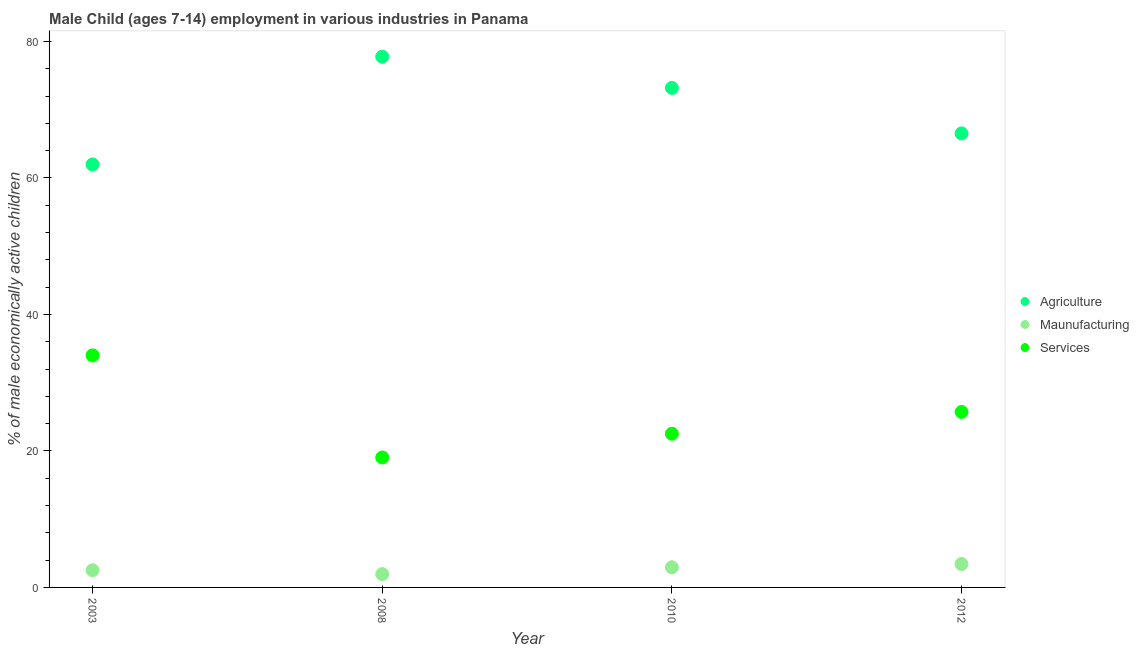How many different coloured dotlines are there?
Offer a very short reply. 3. What is the percentage of economically active children in manufacturing in 2003?
Your answer should be compact. 2.52. Across all years, what is the maximum percentage of economically active children in agriculture?
Give a very brief answer. 77.76. Across all years, what is the minimum percentage of economically active children in manufacturing?
Your answer should be very brief. 1.95. What is the total percentage of economically active children in agriculture in the graph?
Your response must be concise. 279.44. What is the difference between the percentage of economically active children in manufacturing in 2010 and that in 2012?
Keep it short and to the point. -0.48. What is the difference between the percentage of economically active children in manufacturing in 2012 and the percentage of economically active children in agriculture in 2008?
Offer a terse response. -74.33. What is the average percentage of economically active children in manufacturing per year?
Your answer should be compact. 2.71. In the year 2003, what is the difference between the percentage of economically active children in agriculture and percentage of economically active children in services?
Offer a terse response. 27.97. What is the ratio of the percentage of economically active children in manufacturing in 2003 to that in 2012?
Your answer should be very brief. 0.73. Is the difference between the percentage of economically active children in agriculture in 2003 and 2012 greater than the difference between the percentage of economically active children in manufacturing in 2003 and 2012?
Offer a very short reply. No. What is the difference between the highest and the second highest percentage of economically active children in manufacturing?
Your answer should be very brief. 0.48. What is the difference between the highest and the lowest percentage of economically active children in services?
Give a very brief answer. 14.96. Is the sum of the percentage of economically active children in agriculture in 2003 and 2008 greater than the maximum percentage of economically active children in manufacturing across all years?
Offer a very short reply. Yes. Is the percentage of economically active children in manufacturing strictly greater than the percentage of economically active children in services over the years?
Ensure brevity in your answer.  No. Is the percentage of economically active children in services strictly less than the percentage of economically active children in manufacturing over the years?
Provide a succinct answer. No. How many dotlines are there?
Your answer should be compact. 3. How many years are there in the graph?
Offer a terse response. 4. What is the difference between two consecutive major ticks on the Y-axis?
Keep it short and to the point. 20. Are the values on the major ticks of Y-axis written in scientific E-notation?
Offer a terse response. No. Does the graph contain any zero values?
Your response must be concise. No. Where does the legend appear in the graph?
Your answer should be compact. Center right. What is the title of the graph?
Your answer should be very brief. Male Child (ages 7-14) employment in various industries in Panama. Does "Capital account" appear as one of the legend labels in the graph?
Your response must be concise. No. What is the label or title of the X-axis?
Offer a very short reply. Year. What is the label or title of the Y-axis?
Provide a short and direct response. % of male economically active children. What is the % of male economically active children of Agriculture in 2003?
Give a very brief answer. 61.97. What is the % of male economically active children of Maunufacturing in 2003?
Your response must be concise. 2.52. What is the % of male economically active children of Agriculture in 2008?
Offer a very short reply. 77.76. What is the % of male economically active children of Maunufacturing in 2008?
Keep it short and to the point. 1.95. What is the % of male economically active children of Services in 2008?
Make the answer very short. 19.04. What is the % of male economically active children of Agriculture in 2010?
Offer a very short reply. 73.19. What is the % of male economically active children in Maunufacturing in 2010?
Offer a very short reply. 2.95. What is the % of male economically active children in Services in 2010?
Make the answer very short. 22.52. What is the % of male economically active children in Agriculture in 2012?
Ensure brevity in your answer.  66.52. What is the % of male economically active children of Maunufacturing in 2012?
Offer a very short reply. 3.43. What is the % of male economically active children of Services in 2012?
Your response must be concise. 25.71. Across all years, what is the maximum % of male economically active children of Agriculture?
Keep it short and to the point. 77.76. Across all years, what is the maximum % of male economically active children in Maunufacturing?
Keep it short and to the point. 3.43. Across all years, what is the maximum % of male economically active children in Services?
Your answer should be very brief. 34. Across all years, what is the minimum % of male economically active children of Agriculture?
Your answer should be very brief. 61.97. Across all years, what is the minimum % of male economically active children in Maunufacturing?
Keep it short and to the point. 1.95. Across all years, what is the minimum % of male economically active children in Services?
Your answer should be very brief. 19.04. What is the total % of male economically active children of Agriculture in the graph?
Ensure brevity in your answer.  279.44. What is the total % of male economically active children of Maunufacturing in the graph?
Make the answer very short. 10.85. What is the total % of male economically active children of Services in the graph?
Offer a very short reply. 101.27. What is the difference between the % of male economically active children in Agriculture in 2003 and that in 2008?
Give a very brief answer. -15.79. What is the difference between the % of male economically active children of Maunufacturing in 2003 and that in 2008?
Keep it short and to the point. 0.57. What is the difference between the % of male economically active children in Services in 2003 and that in 2008?
Give a very brief answer. 14.96. What is the difference between the % of male economically active children of Agriculture in 2003 and that in 2010?
Keep it short and to the point. -11.22. What is the difference between the % of male economically active children of Maunufacturing in 2003 and that in 2010?
Ensure brevity in your answer.  -0.43. What is the difference between the % of male economically active children of Services in 2003 and that in 2010?
Give a very brief answer. 11.48. What is the difference between the % of male economically active children in Agriculture in 2003 and that in 2012?
Ensure brevity in your answer.  -4.55. What is the difference between the % of male economically active children in Maunufacturing in 2003 and that in 2012?
Give a very brief answer. -0.91. What is the difference between the % of male economically active children of Services in 2003 and that in 2012?
Your answer should be very brief. 8.29. What is the difference between the % of male economically active children of Agriculture in 2008 and that in 2010?
Give a very brief answer. 4.57. What is the difference between the % of male economically active children in Services in 2008 and that in 2010?
Give a very brief answer. -3.48. What is the difference between the % of male economically active children of Agriculture in 2008 and that in 2012?
Give a very brief answer. 11.24. What is the difference between the % of male economically active children of Maunufacturing in 2008 and that in 2012?
Offer a very short reply. -1.48. What is the difference between the % of male economically active children of Services in 2008 and that in 2012?
Offer a terse response. -6.67. What is the difference between the % of male economically active children in Agriculture in 2010 and that in 2012?
Your answer should be compact. 6.67. What is the difference between the % of male economically active children of Maunufacturing in 2010 and that in 2012?
Keep it short and to the point. -0.48. What is the difference between the % of male economically active children of Services in 2010 and that in 2012?
Offer a very short reply. -3.19. What is the difference between the % of male economically active children in Agriculture in 2003 and the % of male economically active children in Maunufacturing in 2008?
Offer a terse response. 60.02. What is the difference between the % of male economically active children in Agriculture in 2003 and the % of male economically active children in Services in 2008?
Make the answer very short. 42.93. What is the difference between the % of male economically active children in Maunufacturing in 2003 and the % of male economically active children in Services in 2008?
Provide a short and direct response. -16.52. What is the difference between the % of male economically active children of Agriculture in 2003 and the % of male economically active children of Maunufacturing in 2010?
Provide a short and direct response. 59.02. What is the difference between the % of male economically active children of Agriculture in 2003 and the % of male economically active children of Services in 2010?
Your answer should be very brief. 39.45. What is the difference between the % of male economically active children in Agriculture in 2003 and the % of male economically active children in Maunufacturing in 2012?
Your answer should be very brief. 58.54. What is the difference between the % of male economically active children in Agriculture in 2003 and the % of male economically active children in Services in 2012?
Give a very brief answer. 36.26. What is the difference between the % of male economically active children of Maunufacturing in 2003 and the % of male economically active children of Services in 2012?
Keep it short and to the point. -23.19. What is the difference between the % of male economically active children of Agriculture in 2008 and the % of male economically active children of Maunufacturing in 2010?
Your answer should be very brief. 74.81. What is the difference between the % of male economically active children of Agriculture in 2008 and the % of male economically active children of Services in 2010?
Give a very brief answer. 55.24. What is the difference between the % of male economically active children of Maunufacturing in 2008 and the % of male economically active children of Services in 2010?
Make the answer very short. -20.57. What is the difference between the % of male economically active children in Agriculture in 2008 and the % of male economically active children in Maunufacturing in 2012?
Your response must be concise. 74.33. What is the difference between the % of male economically active children of Agriculture in 2008 and the % of male economically active children of Services in 2012?
Make the answer very short. 52.05. What is the difference between the % of male economically active children in Maunufacturing in 2008 and the % of male economically active children in Services in 2012?
Your answer should be very brief. -23.76. What is the difference between the % of male economically active children of Agriculture in 2010 and the % of male economically active children of Maunufacturing in 2012?
Offer a very short reply. 69.76. What is the difference between the % of male economically active children of Agriculture in 2010 and the % of male economically active children of Services in 2012?
Keep it short and to the point. 47.48. What is the difference between the % of male economically active children of Maunufacturing in 2010 and the % of male economically active children of Services in 2012?
Your response must be concise. -22.76. What is the average % of male economically active children in Agriculture per year?
Give a very brief answer. 69.86. What is the average % of male economically active children of Maunufacturing per year?
Offer a very short reply. 2.71. What is the average % of male economically active children in Services per year?
Your response must be concise. 25.32. In the year 2003, what is the difference between the % of male economically active children in Agriculture and % of male economically active children in Maunufacturing?
Offer a terse response. 59.45. In the year 2003, what is the difference between the % of male economically active children of Agriculture and % of male economically active children of Services?
Offer a terse response. 27.97. In the year 2003, what is the difference between the % of male economically active children in Maunufacturing and % of male economically active children in Services?
Give a very brief answer. -31.48. In the year 2008, what is the difference between the % of male economically active children in Agriculture and % of male economically active children in Maunufacturing?
Give a very brief answer. 75.81. In the year 2008, what is the difference between the % of male economically active children in Agriculture and % of male economically active children in Services?
Keep it short and to the point. 58.72. In the year 2008, what is the difference between the % of male economically active children of Maunufacturing and % of male economically active children of Services?
Ensure brevity in your answer.  -17.09. In the year 2010, what is the difference between the % of male economically active children of Agriculture and % of male economically active children of Maunufacturing?
Give a very brief answer. 70.24. In the year 2010, what is the difference between the % of male economically active children of Agriculture and % of male economically active children of Services?
Offer a very short reply. 50.67. In the year 2010, what is the difference between the % of male economically active children of Maunufacturing and % of male economically active children of Services?
Offer a very short reply. -19.57. In the year 2012, what is the difference between the % of male economically active children in Agriculture and % of male economically active children in Maunufacturing?
Ensure brevity in your answer.  63.09. In the year 2012, what is the difference between the % of male economically active children of Agriculture and % of male economically active children of Services?
Keep it short and to the point. 40.81. In the year 2012, what is the difference between the % of male economically active children in Maunufacturing and % of male economically active children in Services?
Your answer should be compact. -22.28. What is the ratio of the % of male economically active children of Agriculture in 2003 to that in 2008?
Your answer should be very brief. 0.8. What is the ratio of the % of male economically active children in Maunufacturing in 2003 to that in 2008?
Provide a short and direct response. 1.29. What is the ratio of the % of male economically active children in Services in 2003 to that in 2008?
Provide a succinct answer. 1.79. What is the ratio of the % of male economically active children of Agriculture in 2003 to that in 2010?
Offer a terse response. 0.85. What is the ratio of the % of male economically active children in Maunufacturing in 2003 to that in 2010?
Ensure brevity in your answer.  0.85. What is the ratio of the % of male economically active children in Services in 2003 to that in 2010?
Offer a terse response. 1.51. What is the ratio of the % of male economically active children of Agriculture in 2003 to that in 2012?
Provide a succinct answer. 0.93. What is the ratio of the % of male economically active children in Maunufacturing in 2003 to that in 2012?
Your response must be concise. 0.73. What is the ratio of the % of male economically active children in Services in 2003 to that in 2012?
Give a very brief answer. 1.32. What is the ratio of the % of male economically active children of Agriculture in 2008 to that in 2010?
Give a very brief answer. 1.06. What is the ratio of the % of male economically active children in Maunufacturing in 2008 to that in 2010?
Provide a succinct answer. 0.66. What is the ratio of the % of male economically active children in Services in 2008 to that in 2010?
Provide a succinct answer. 0.85. What is the ratio of the % of male economically active children in Agriculture in 2008 to that in 2012?
Give a very brief answer. 1.17. What is the ratio of the % of male economically active children in Maunufacturing in 2008 to that in 2012?
Your answer should be compact. 0.57. What is the ratio of the % of male economically active children of Services in 2008 to that in 2012?
Give a very brief answer. 0.74. What is the ratio of the % of male economically active children in Agriculture in 2010 to that in 2012?
Provide a succinct answer. 1.1. What is the ratio of the % of male economically active children of Maunufacturing in 2010 to that in 2012?
Your answer should be very brief. 0.86. What is the ratio of the % of male economically active children of Services in 2010 to that in 2012?
Ensure brevity in your answer.  0.88. What is the difference between the highest and the second highest % of male economically active children of Agriculture?
Offer a very short reply. 4.57. What is the difference between the highest and the second highest % of male economically active children of Maunufacturing?
Your response must be concise. 0.48. What is the difference between the highest and the second highest % of male economically active children of Services?
Ensure brevity in your answer.  8.29. What is the difference between the highest and the lowest % of male economically active children of Agriculture?
Offer a very short reply. 15.79. What is the difference between the highest and the lowest % of male economically active children in Maunufacturing?
Provide a short and direct response. 1.48. What is the difference between the highest and the lowest % of male economically active children of Services?
Your response must be concise. 14.96. 